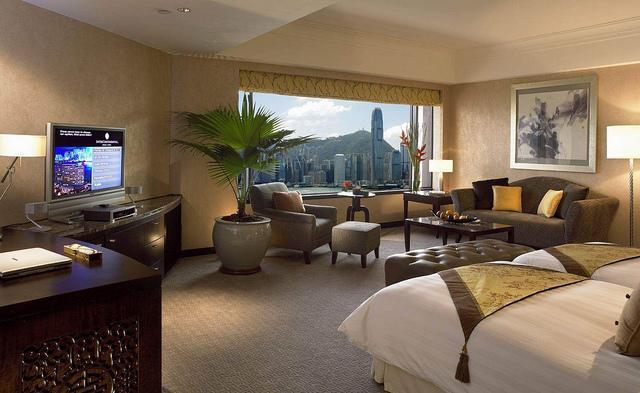How many beds can be seen?
Give a very brief answer. 2. How many people are here?
Give a very brief answer. 0. 